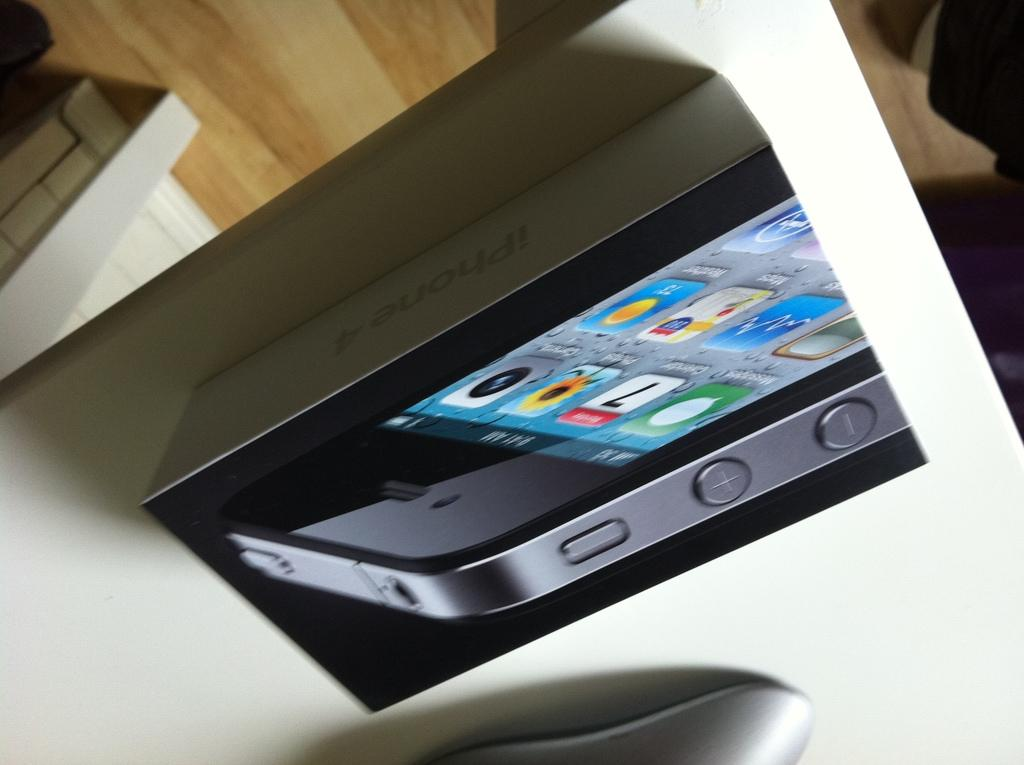<image>
Summarize the visual content of the image. the number 7 is on the white calendar of the phone 